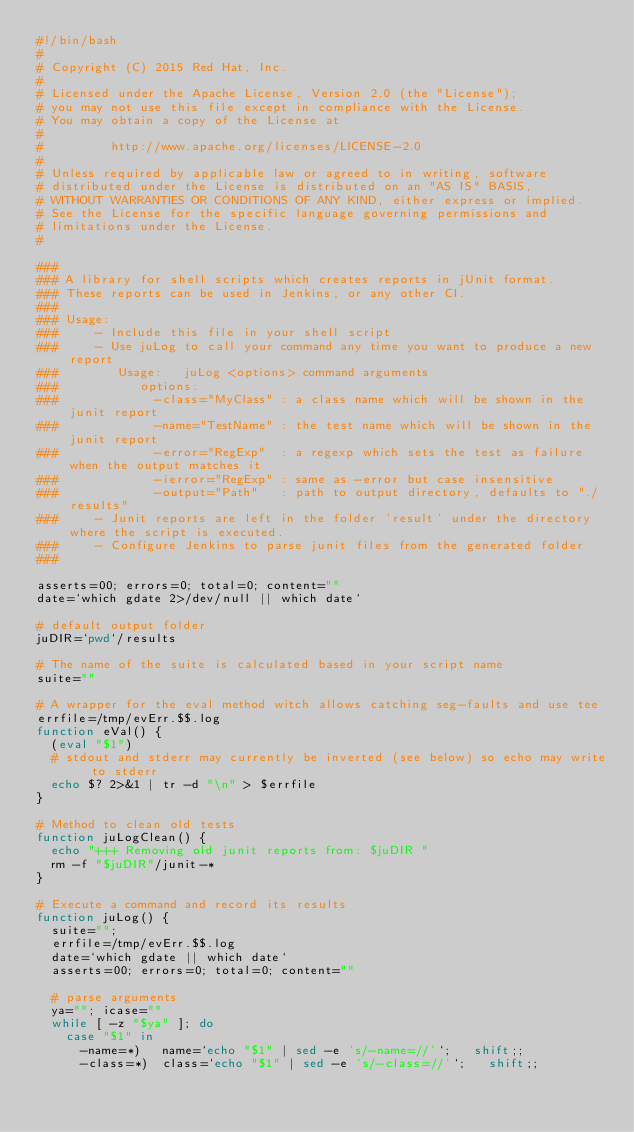Convert code to text. <code><loc_0><loc_0><loc_500><loc_500><_Bash_>#!/bin/bash
#
# Copyright (C) 2015 Red Hat, Inc.
#
# Licensed under the Apache License, Version 2.0 (the "License");
# you may not use this file except in compliance with the License.
# You may obtain a copy of the License at
#
#         http://www.apache.org/licenses/LICENSE-2.0
#
# Unless required by applicable law or agreed to in writing, software
# distributed under the License is distributed on an "AS IS" BASIS,
# WITHOUT WARRANTIES OR CONDITIONS OF ANY KIND, either express or implied.
# See the License for the specific language governing permissions and
# limitations under the License.
#

###
### A library for shell scripts which creates reports in jUnit format.
### These reports can be used in Jenkins, or any other CI.
###
### Usage:
###     - Include this file in your shell script
###     - Use juLog to call your command any time you want to produce a new report
###        Usage:   juLog <options> command arguments
###           options:
###             -class="MyClass" : a class name which will be shown in the junit report
###             -name="TestName" : the test name which will be shown in the junit report
###             -error="RegExp"  : a regexp which sets the test as failure when the output matches it
###             -ierror="RegExp" : same as -error but case insensitive
###             -output="Path"   : path to output directory, defaults to "./results"
###     - Junit reports are left in the folder 'result' under the directory where the script is executed.
###     - Configure Jenkins to parse junit files from the generated folder
###

asserts=00; errors=0; total=0; content=""
date=`which gdate 2>/dev/null || which date`

# default output folder
juDIR=`pwd`/results

# The name of the suite is calculated based in your script name
suite=""

# A wrapper for the eval method witch allows catching seg-faults and use tee
errfile=/tmp/evErr.$$.log
function eVal() {
  (eval "$1")
  # stdout and stderr may currently be inverted (see below) so echo may write to stderr
  echo $? 2>&1 | tr -d "\n" > $errfile
}

# Method to clean old tests
function juLogClean() {
  echo "+++ Removing old junit reports from: $juDIR "
  rm -f "$juDIR"/junit-*
}

# Execute a command and record its results
function juLog() {
  suite="";
  errfile=/tmp/evErr.$$.log
  date=`which gdate || which date`
  asserts=00; errors=0; total=0; content=""

  # parse arguments
  ya=""; icase=""
  while [ -z "$ya" ]; do
    case "$1" in
  	  -name=*)   name=`echo "$1" | sed -e 's/-name=//'`;   shift;;
  	  -class=*)  class=`echo "$1" | sed -e 's/-class=//'`;   shift;;</code> 